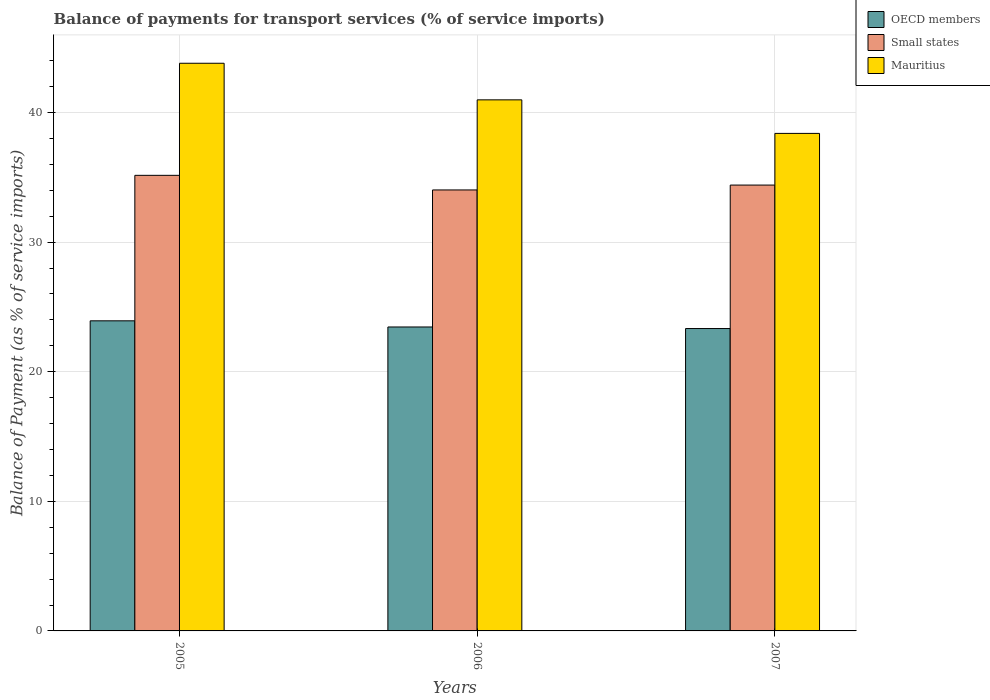How many different coloured bars are there?
Offer a very short reply. 3. Are the number of bars per tick equal to the number of legend labels?
Your answer should be compact. Yes. What is the balance of payments for transport services in OECD members in 2005?
Your response must be concise. 23.93. Across all years, what is the maximum balance of payments for transport services in Small states?
Your response must be concise. 35.16. Across all years, what is the minimum balance of payments for transport services in Mauritius?
Your answer should be compact. 38.39. What is the total balance of payments for transport services in OECD members in the graph?
Your response must be concise. 70.72. What is the difference between the balance of payments for transport services in Mauritius in 2005 and that in 2007?
Keep it short and to the point. 5.41. What is the difference between the balance of payments for transport services in Mauritius in 2007 and the balance of payments for transport services in OECD members in 2005?
Ensure brevity in your answer.  14.46. What is the average balance of payments for transport services in Small states per year?
Provide a short and direct response. 34.53. In the year 2005, what is the difference between the balance of payments for transport services in Mauritius and balance of payments for transport services in Small states?
Offer a terse response. 8.65. What is the ratio of the balance of payments for transport services in OECD members in 2005 to that in 2007?
Your answer should be very brief. 1.03. Is the difference between the balance of payments for transport services in Mauritius in 2006 and 2007 greater than the difference between the balance of payments for transport services in Small states in 2006 and 2007?
Your answer should be compact. Yes. What is the difference between the highest and the second highest balance of payments for transport services in Small states?
Offer a very short reply. 0.75. What is the difference between the highest and the lowest balance of payments for transport services in Mauritius?
Your answer should be very brief. 5.41. Is the sum of the balance of payments for transport services in OECD members in 2005 and 2007 greater than the maximum balance of payments for transport services in Small states across all years?
Provide a succinct answer. Yes. What does the 3rd bar from the left in 2007 represents?
Make the answer very short. Mauritius. What does the 2nd bar from the right in 2005 represents?
Make the answer very short. Small states. Are the values on the major ticks of Y-axis written in scientific E-notation?
Make the answer very short. No. Does the graph contain any zero values?
Provide a succinct answer. No. Does the graph contain grids?
Make the answer very short. Yes. Where does the legend appear in the graph?
Ensure brevity in your answer.  Top right. How many legend labels are there?
Offer a very short reply. 3. What is the title of the graph?
Offer a very short reply. Balance of payments for transport services (% of service imports). Does "Guinea-Bissau" appear as one of the legend labels in the graph?
Your answer should be very brief. No. What is the label or title of the X-axis?
Give a very brief answer. Years. What is the label or title of the Y-axis?
Your answer should be very brief. Balance of Payment (as % of service imports). What is the Balance of Payment (as % of service imports) of OECD members in 2005?
Offer a terse response. 23.93. What is the Balance of Payment (as % of service imports) of Small states in 2005?
Your answer should be compact. 35.16. What is the Balance of Payment (as % of service imports) in Mauritius in 2005?
Make the answer very short. 43.81. What is the Balance of Payment (as % of service imports) in OECD members in 2006?
Make the answer very short. 23.46. What is the Balance of Payment (as % of service imports) in Small states in 2006?
Offer a terse response. 34.03. What is the Balance of Payment (as % of service imports) in Mauritius in 2006?
Your answer should be compact. 40.98. What is the Balance of Payment (as % of service imports) in OECD members in 2007?
Offer a terse response. 23.33. What is the Balance of Payment (as % of service imports) of Small states in 2007?
Make the answer very short. 34.41. What is the Balance of Payment (as % of service imports) in Mauritius in 2007?
Your response must be concise. 38.39. Across all years, what is the maximum Balance of Payment (as % of service imports) in OECD members?
Provide a short and direct response. 23.93. Across all years, what is the maximum Balance of Payment (as % of service imports) in Small states?
Your answer should be compact. 35.16. Across all years, what is the maximum Balance of Payment (as % of service imports) in Mauritius?
Provide a short and direct response. 43.81. Across all years, what is the minimum Balance of Payment (as % of service imports) in OECD members?
Provide a succinct answer. 23.33. Across all years, what is the minimum Balance of Payment (as % of service imports) of Small states?
Keep it short and to the point. 34.03. Across all years, what is the minimum Balance of Payment (as % of service imports) in Mauritius?
Your response must be concise. 38.39. What is the total Balance of Payment (as % of service imports) of OECD members in the graph?
Your response must be concise. 70.72. What is the total Balance of Payment (as % of service imports) of Small states in the graph?
Your answer should be very brief. 103.59. What is the total Balance of Payment (as % of service imports) in Mauritius in the graph?
Your answer should be compact. 123.18. What is the difference between the Balance of Payment (as % of service imports) in OECD members in 2005 and that in 2006?
Your answer should be compact. 0.47. What is the difference between the Balance of Payment (as % of service imports) of Small states in 2005 and that in 2006?
Your answer should be very brief. 1.13. What is the difference between the Balance of Payment (as % of service imports) of Mauritius in 2005 and that in 2006?
Provide a succinct answer. 2.82. What is the difference between the Balance of Payment (as % of service imports) of OECD members in 2005 and that in 2007?
Ensure brevity in your answer.  0.6. What is the difference between the Balance of Payment (as % of service imports) in Small states in 2005 and that in 2007?
Provide a short and direct response. 0.75. What is the difference between the Balance of Payment (as % of service imports) in Mauritius in 2005 and that in 2007?
Keep it short and to the point. 5.41. What is the difference between the Balance of Payment (as % of service imports) in OECD members in 2006 and that in 2007?
Offer a terse response. 0.12. What is the difference between the Balance of Payment (as % of service imports) in Small states in 2006 and that in 2007?
Provide a succinct answer. -0.38. What is the difference between the Balance of Payment (as % of service imports) of Mauritius in 2006 and that in 2007?
Provide a short and direct response. 2.59. What is the difference between the Balance of Payment (as % of service imports) in OECD members in 2005 and the Balance of Payment (as % of service imports) in Small states in 2006?
Provide a succinct answer. -10.1. What is the difference between the Balance of Payment (as % of service imports) in OECD members in 2005 and the Balance of Payment (as % of service imports) in Mauritius in 2006?
Offer a very short reply. -17.05. What is the difference between the Balance of Payment (as % of service imports) in Small states in 2005 and the Balance of Payment (as % of service imports) in Mauritius in 2006?
Your answer should be very brief. -5.83. What is the difference between the Balance of Payment (as % of service imports) of OECD members in 2005 and the Balance of Payment (as % of service imports) of Small states in 2007?
Ensure brevity in your answer.  -10.48. What is the difference between the Balance of Payment (as % of service imports) of OECD members in 2005 and the Balance of Payment (as % of service imports) of Mauritius in 2007?
Your answer should be compact. -14.46. What is the difference between the Balance of Payment (as % of service imports) of Small states in 2005 and the Balance of Payment (as % of service imports) of Mauritius in 2007?
Offer a terse response. -3.24. What is the difference between the Balance of Payment (as % of service imports) in OECD members in 2006 and the Balance of Payment (as % of service imports) in Small states in 2007?
Provide a short and direct response. -10.95. What is the difference between the Balance of Payment (as % of service imports) in OECD members in 2006 and the Balance of Payment (as % of service imports) in Mauritius in 2007?
Make the answer very short. -14.94. What is the difference between the Balance of Payment (as % of service imports) of Small states in 2006 and the Balance of Payment (as % of service imports) of Mauritius in 2007?
Your answer should be very brief. -4.36. What is the average Balance of Payment (as % of service imports) in OECD members per year?
Provide a short and direct response. 23.57. What is the average Balance of Payment (as % of service imports) in Small states per year?
Make the answer very short. 34.53. What is the average Balance of Payment (as % of service imports) in Mauritius per year?
Your answer should be compact. 41.06. In the year 2005, what is the difference between the Balance of Payment (as % of service imports) in OECD members and Balance of Payment (as % of service imports) in Small states?
Offer a terse response. -11.23. In the year 2005, what is the difference between the Balance of Payment (as % of service imports) in OECD members and Balance of Payment (as % of service imports) in Mauritius?
Give a very brief answer. -19.88. In the year 2005, what is the difference between the Balance of Payment (as % of service imports) in Small states and Balance of Payment (as % of service imports) in Mauritius?
Give a very brief answer. -8.65. In the year 2006, what is the difference between the Balance of Payment (as % of service imports) in OECD members and Balance of Payment (as % of service imports) in Small states?
Your response must be concise. -10.57. In the year 2006, what is the difference between the Balance of Payment (as % of service imports) in OECD members and Balance of Payment (as % of service imports) in Mauritius?
Offer a very short reply. -17.53. In the year 2006, what is the difference between the Balance of Payment (as % of service imports) in Small states and Balance of Payment (as % of service imports) in Mauritius?
Offer a very short reply. -6.95. In the year 2007, what is the difference between the Balance of Payment (as % of service imports) of OECD members and Balance of Payment (as % of service imports) of Small states?
Offer a terse response. -11.07. In the year 2007, what is the difference between the Balance of Payment (as % of service imports) in OECD members and Balance of Payment (as % of service imports) in Mauritius?
Keep it short and to the point. -15.06. In the year 2007, what is the difference between the Balance of Payment (as % of service imports) in Small states and Balance of Payment (as % of service imports) in Mauritius?
Provide a short and direct response. -3.99. What is the ratio of the Balance of Payment (as % of service imports) in OECD members in 2005 to that in 2006?
Offer a very short reply. 1.02. What is the ratio of the Balance of Payment (as % of service imports) of Small states in 2005 to that in 2006?
Provide a succinct answer. 1.03. What is the ratio of the Balance of Payment (as % of service imports) in Mauritius in 2005 to that in 2006?
Provide a succinct answer. 1.07. What is the ratio of the Balance of Payment (as % of service imports) of OECD members in 2005 to that in 2007?
Provide a short and direct response. 1.03. What is the ratio of the Balance of Payment (as % of service imports) in Small states in 2005 to that in 2007?
Provide a short and direct response. 1.02. What is the ratio of the Balance of Payment (as % of service imports) of Mauritius in 2005 to that in 2007?
Provide a succinct answer. 1.14. What is the ratio of the Balance of Payment (as % of service imports) in OECD members in 2006 to that in 2007?
Give a very brief answer. 1.01. What is the ratio of the Balance of Payment (as % of service imports) in Mauritius in 2006 to that in 2007?
Your response must be concise. 1.07. What is the difference between the highest and the second highest Balance of Payment (as % of service imports) of OECD members?
Make the answer very short. 0.47. What is the difference between the highest and the second highest Balance of Payment (as % of service imports) of Small states?
Provide a succinct answer. 0.75. What is the difference between the highest and the second highest Balance of Payment (as % of service imports) in Mauritius?
Your answer should be very brief. 2.82. What is the difference between the highest and the lowest Balance of Payment (as % of service imports) of OECD members?
Your answer should be very brief. 0.6. What is the difference between the highest and the lowest Balance of Payment (as % of service imports) of Small states?
Your answer should be compact. 1.13. What is the difference between the highest and the lowest Balance of Payment (as % of service imports) in Mauritius?
Your answer should be very brief. 5.41. 